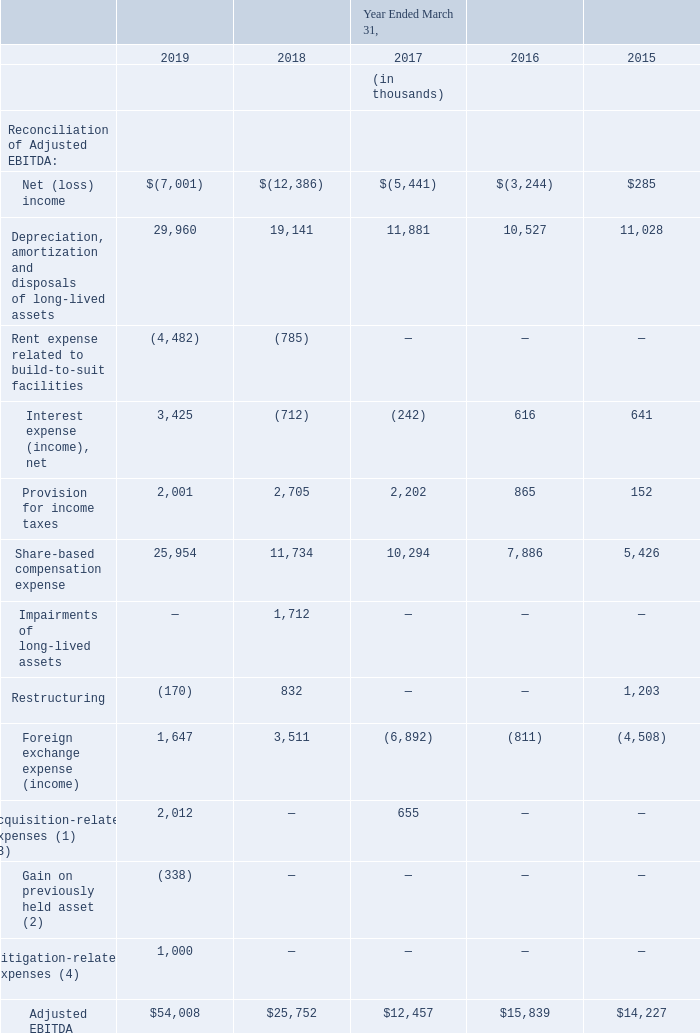(8) Adjusted EBITDA is a non-GAAP financial measure that we define as net (loss) income, adjusted to exclude: depreciation, amortization, disposals and impairment of long-lived assets, acquisition-related gains and expenses, litigation-related expenses, share-based compensation expense, restructuring expense, interest income and interest expense, the provision for income taxes and foreign exchange income (expense). Adjusted EBITDA also includes rent paid in the period related to locations that are accounted for as build-to-suit facilities.
We believe that Adjusted EBITDA provides investors and other users of our financial information consistency and comparability with our past financial performance, facilitates period-to-period comparisons of operations and facilitates comparisons with our peer companies, many of which use a similar non-GAAP financial measure to supplement their GAAP results.
We use Adjusted EBITDA in conjunction with traditional GAAP operating performance measures as part of our overall assessment of our performance, for planning purposes, including the preparation of our annual operating budget, to evaluate the effectiveness of our business strategies, to communicate with our board of directors concerning our financial performance, and for establishing incentive compensation metrics for executives and other senior employees.
We do not place undue reliance on Adjusted EBITDA as a measure of operating performance. This non-GAAP measure should not be considered as a substitute for other measures of financial performance reported in accordance with GAAP. There are limitations to using a non-GAAP financial measure, including that other companies may calculate this measure differently than we do, that it does not reflect our capital expenditures or future requirements for capital expenditures and that it does not reflect changes in, or cash requirements for, our working capital.
The following table presents a reconciliation of net (loss) income to Adjusted EBITDA:
(1) Acquisition-related expenses relate to costs incurred for acquisition activity in the years ended March 31, 2019 and March 31, 2017. See Note 5 of the notes to our consolidated financial statements, included elsewhere in this Annual Report on Form 10-K for further information. (2) Gain on previously held asset relates to the Solebit acquisition. See Note 5 of the notes to our consolidated financial statements, included elsewhere in this Annual Report on Form 10-K for further information.
(3) Amounts in fiscal 2017 adjusted to conform to current year presentation. (4) Litigation-related expenses relate to amounts accrued for loss contingencies. See Note 12 of the notes to our consolidated financial statements, included elsewhere in this Annual Report on Form 10-K for further details.
What is the Adjusted EBITDA in 2019?
Answer scale should be: thousand. $54,008. What is the Adjusted EBITDA in 2018?
Answer scale should be: thousand. $25,752. What was the Net (loss) income in 2019, 2018 and 2017 respectively?
Answer scale should be: thousand. (7,001), (12,386), (5,441). What was the change in the Depreciation, amortization and disposals of long-lived assets from 2018 to 2019?
Answer scale should be: thousand. 29,960 - 19,141
Answer: 10819. What is the average Rent expense related to build-to-suit facilities between 2015-2019?
Answer scale should be: thousand. -(4,482 + 785 + 0 + 0 + 0) / 5
Answer: -1053.4. In which year was Adjusted EBITDA less than 20,000 thousands? Locate and analyze adjusted ebitda in row 17
answer: 2017, 2016, 2015. 